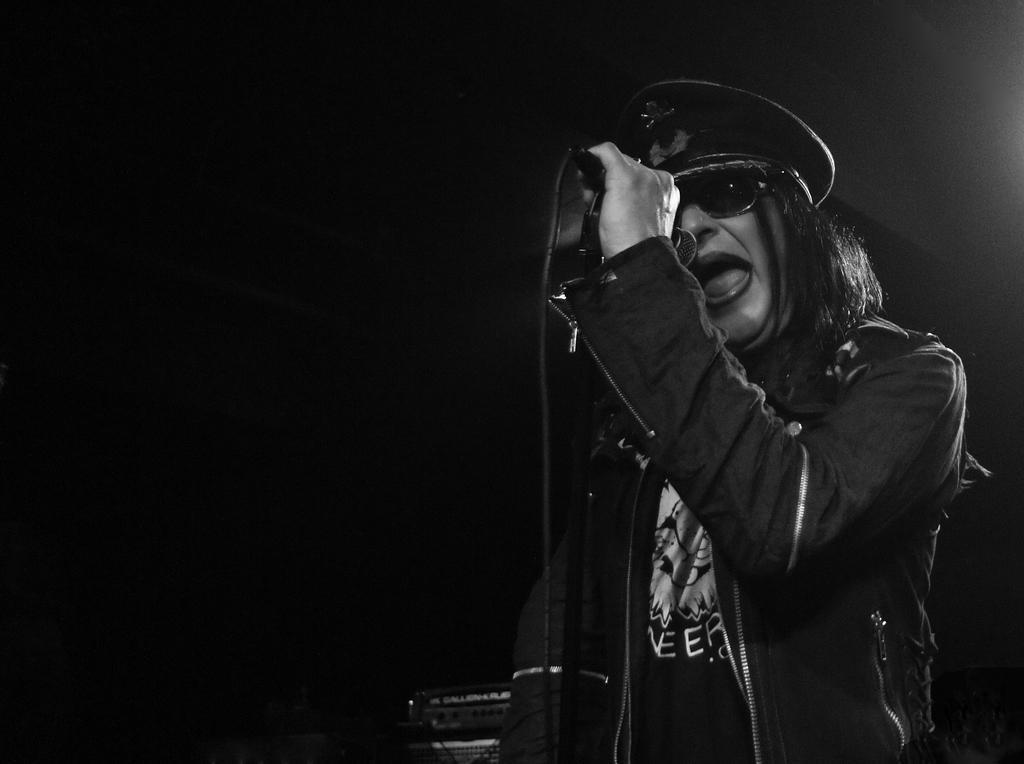What is the main subject of the image? There is a person in the image. What can be observed about the background of the image? The person is on a dark background. What is the person wearing on their head? The person is wearing a cap. What object is the person holding in their hand? The person is holding a mic with her hand. Can you see any wounds on the person in the image? There is no mention of any wounds on the person in the image, so we cannot determine if any are present. How many ladybugs are visible on the person's cap in the image? There are no ladybugs visible on the person's cap in the image. 